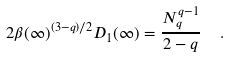Convert formula to latex. <formula><loc_0><loc_0><loc_500><loc_500>2 \beta ( \infty ) ^ { ( 3 - q ) / 2 } D _ { 1 } ( \infty ) = \frac { N _ { q } ^ { q - 1 } } { 2 - q } \ \ .</formula> 